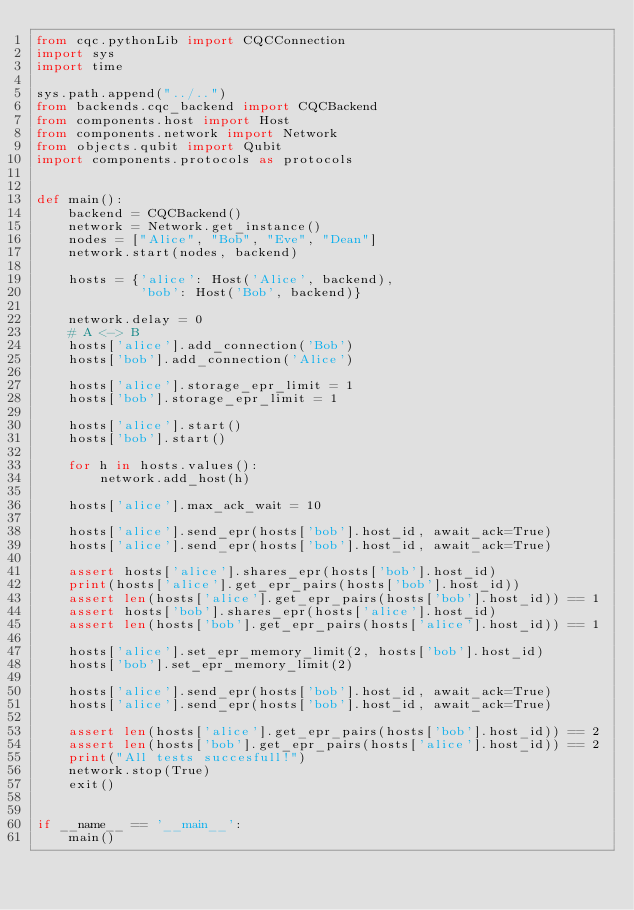<code> <loc_0><loc_0><loc_500><loc_500><_Python_>from cqc.pythonLib import CQCConnection
import sys
import time

sys.path.append("../..")
from backends.cqc_backend import CQCBackend
from components.host import Host
from components.network import Network
from objects.qubit import Qubit
import components.protocols as protocols


def main():
    backend = CQCBackend()
    network = Network.get_instance()
    nodes = ["Alice", "Bob", "Eve", "Dean"]
    network.start(nodes, backend)

    hosts = {'alice': Host('Alice', backend),
             'bob': Host('Bob', backend)}

    network.delay = 0
    # A <-> B
    hosts['alice'].add_connection('Bob')
    hosts['bob'].add_connection('Alice')

    hosts['alice'].storage_epr_limit = 1
    hosts['bob'].storage_epr_limit = 1

    hosts['alice'].start()
    hosts['bob'].start()

    for h in hosts.values():
        network.add_host(h)

    hosts['alice'].max_ack_wait = 10

    hosts['alice'].send_epr(hosts['bob'].host_id, await_ack=True)
    hosts['alice'].send_epr(hosts['bob'].host_id, await_ack=True)

    assert hosts['alice'].shares_epr(hosts['bob'].host_id)
    print(hosts['alice'].get_epr_pairs(hosts['bob'].host_id))
    assert len(hosts['alice'].get_epr_pairs(hosts['bob'].host_id)) == 1
    assert hosts['bob'].shares_epr(hosts['alice'].host_id)
    assert len(hosts['bob'].get_epr_pairs(hosts['alice'].host_id)) == 1

    hosts['alice'].set_epr_memory_limit(2, hosts['bob'].host_id)
    hosts['bob'].set_epr_memory_limit(2)

    hosts['alice'].send_epr(hosts['bob'].host_id, await_ack=True)
    hosts['alice'].send_epr(hosts['bob'].host_id, await_ack=True)

    assert len(hosts['alice'].get_epr_pairs(hosts['bob'].host_id)) == 2
    assert len(hosts['bob'].get_epr_pairs(hosts['alice'].host_id)) == 2
    print("All tests succesfull!")
    network.stop(True)
    exit()


if __name__ == '__main__':
    main()
</code> 